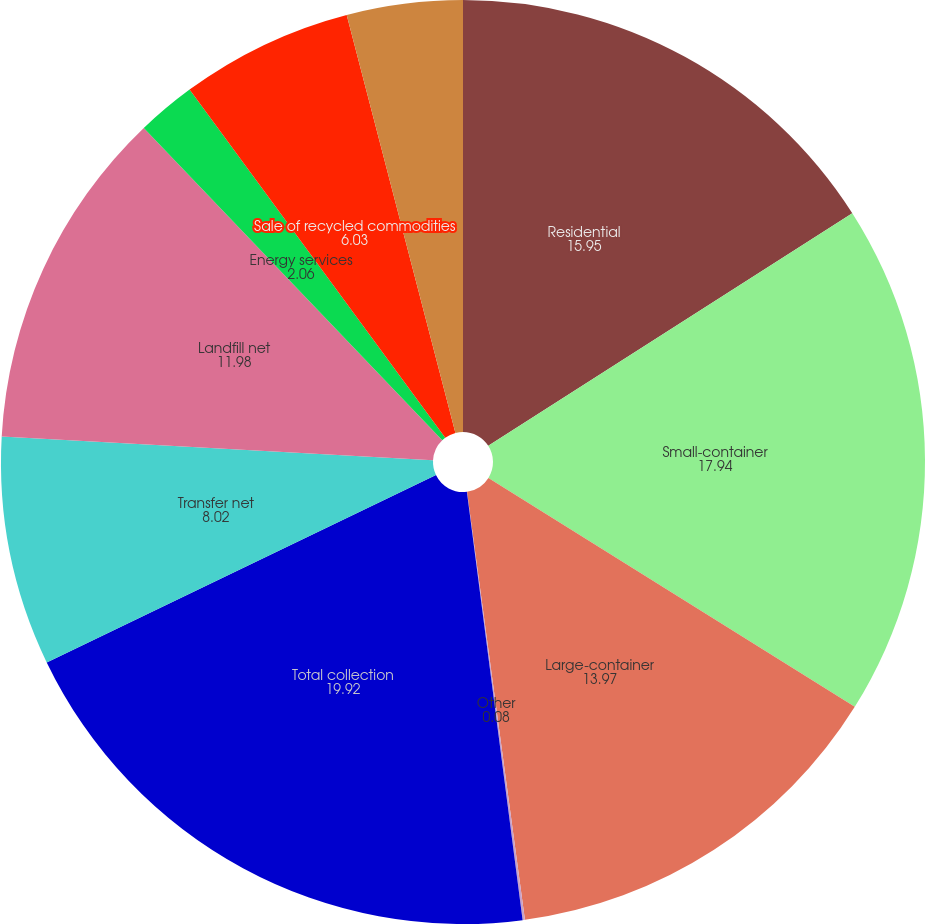<chart> <loc_0><loc_0><loc_500><loc_500><pie_chart><fcel>Residential<fcel>Small-container<fcel>Large-container<fcel>Other<fcel>Total collection<fcel>Transfer net<fcel>Landfill net<fcel>Energy services<fcel>Sale of recycled commodities<fcel>Other non-core<nl><fcel>15.95%<fcel>17.94%<fcel>13.97%<fcel>0.08%<fcel>19.92%<fcel>8.02%<fcel>11.98%<fcel>2.06%<fcel>6.03%<fcel>4.05%<nl></chart> 